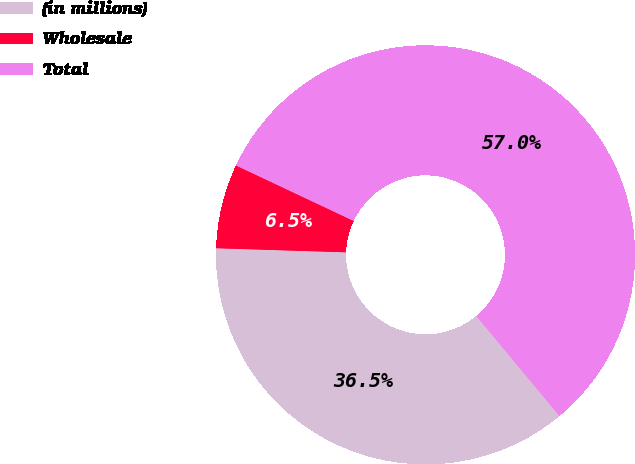<chart> <loc_0><loc_0><loc_500><loc_500><pie_chart><fcel>(in millions)<fcel>Wholesale<fcel>Total<nl><fcel>36.54%<fcel>6.51%<fcel>56.95%<nl></chart> 